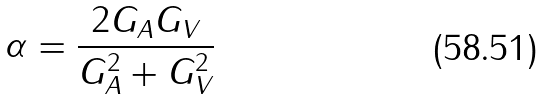<formula> <loc_0><loc_0><loc_500><loc_500>\alpha = \frac { 2 G _ { A } G _ { V } } { G _ { A } ^ { 2 } + G _ { V } ^ { 2 } }</formula> 